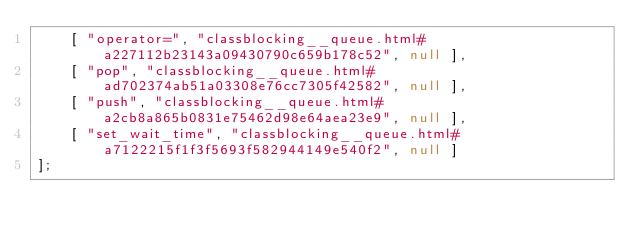<code> <loc_0><loc_0><loc_500><loc_500><_JavaScript_>    [ "operator=", "classblocking__queue.html#a227112b23143a09430790c659b178c52", null ],
    [ "pop", "classblocking__queue.html#ad702374ab51a03308e76cc7305f42582", null ],
    [ "push", "classblocking__queue.html#a2cb8a865b0831e75462d98e64aea23e9", null ],
    [ "set_wait_time", "classblocking__queue.html#a7122215f1f3f5693f582944149e540f2", null ]
];</code> 